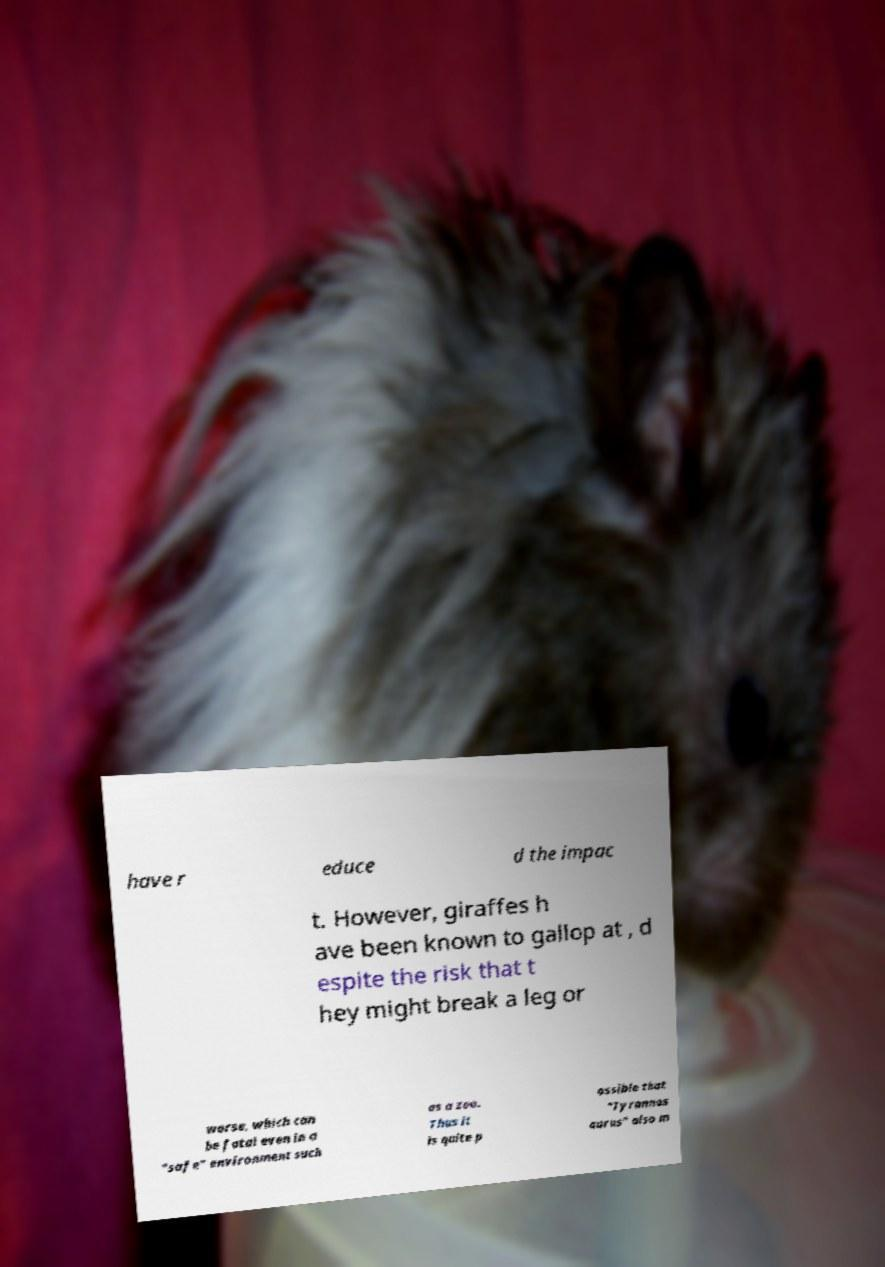Could you extract and type out the text from this image? have r educe d the impac t. However, giraffes h ave been known to gallop at , d espite the risk that t hey might break a leg or worse, which can be fatal even in a "safe" environment such as a zoo. Thus it is quite p ossible that "Tyrannos aurus" also m 